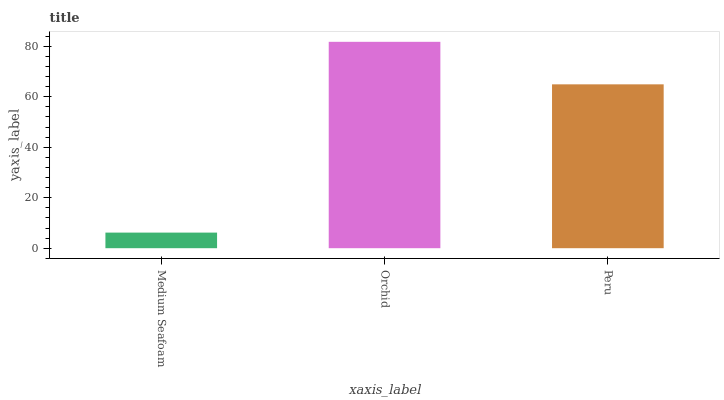Is Medium Seafoam the minimum?
Answer yes or no. Yes. Is Orchid the maximum?
Answer yes or no. Yes. Is Peru the minimum?
Answer yes or no. No. Is Peru the maximum?
Answer yes or no. No. Is Orchid greater than Peru?
Answer yes or no. Yes. Is Peru less than Orchid?
Answer yes or no. Yes. Is Peru greater than Orchid?
Answer yes or no. No. Is Orchid less than Peru?
Answer yes or no. No. Is Peru the high median?
Answer yes or no. Yes. Is Peru the low median?
Answer yes or no. Yes. Is Medium Seafoam the high median?
Answer yes or no. No. Is Medium Seafoam the low median?
Answer yes or no. No. 